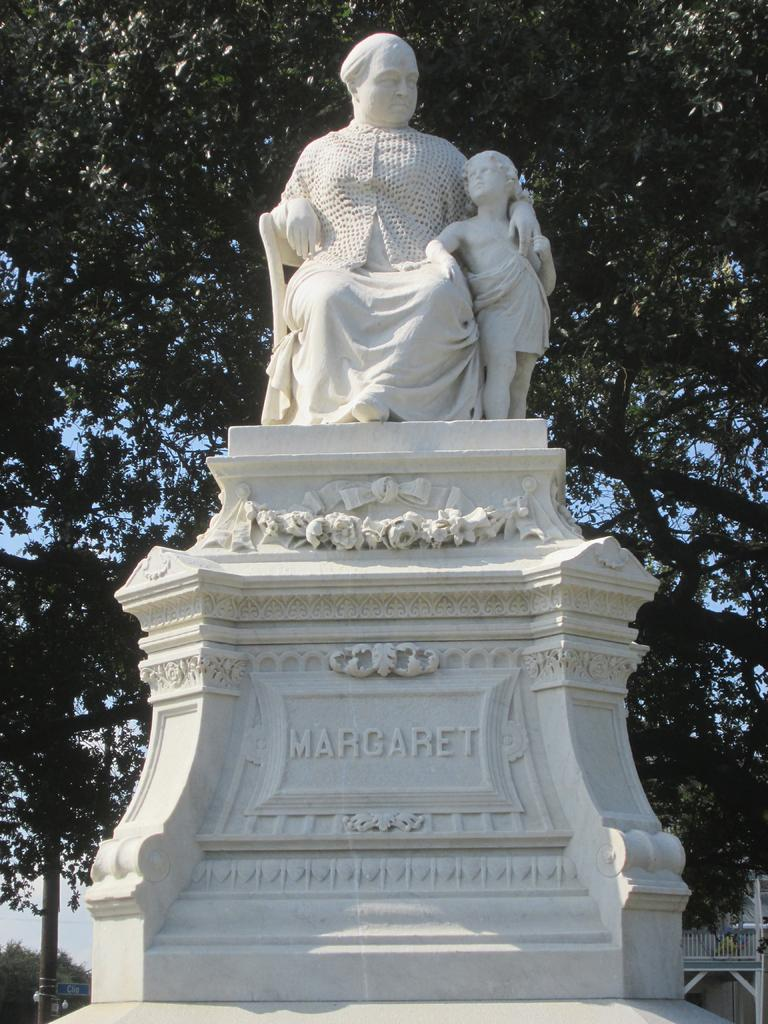What is the main subject of the image? There is a white color sculpture in the image. What does the sculpture depict? The sculpture depicts a man and a boy. What can be seen in the background of the image? There are trees in the background of the image. What other object is present in the image? There is a pole in the image. Is the man driving a car in the sculpture? No, the sculpture does not depict a car or any driving activity. 